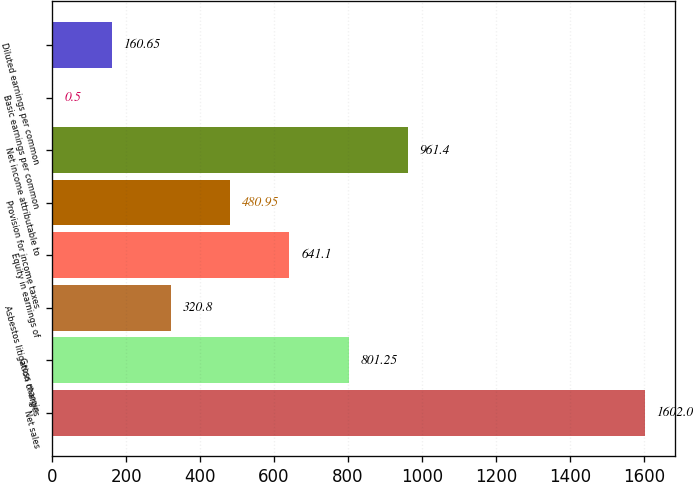Convert chart. <chart><loc_0><loc_0><loc_500><loc_500><bar_chart><fcel>Net sales<fcel>Gross margin<fcel>Asbestos litigation charges<fcel>Equity in earnings of<fcel>Provision for income taxes<fcel>Net income attributable to<fcel>Basic earnings per common<fcel>Diluted earnings per common<nl><fcel>1602<fcel>801.25<fcel>320.8<fcel>641.1<fcel>480.95<fcel>961.4<fcel>0.5<fcel>160.65<nl></chart> 